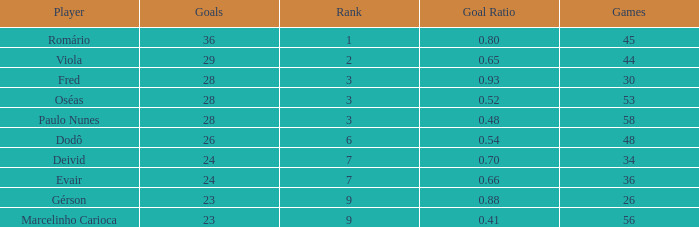How many games have 23 goals with a rank greater than 9? 0.0. 